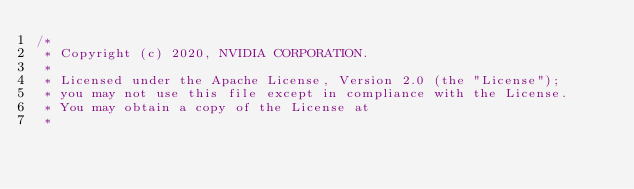Convert code to text. <code><loc_0><loc_0><loc_500><loc_500><_Cuda_>/*
 * Copyright (c) 2020, NVIDIA CORPORATION.
 *
 * Licensed under the Apache License, Version 2.0 (the "License");
 * you may not use this file except in compliance with the License.
 * You may obtain a copy of the License at
 *</code> 